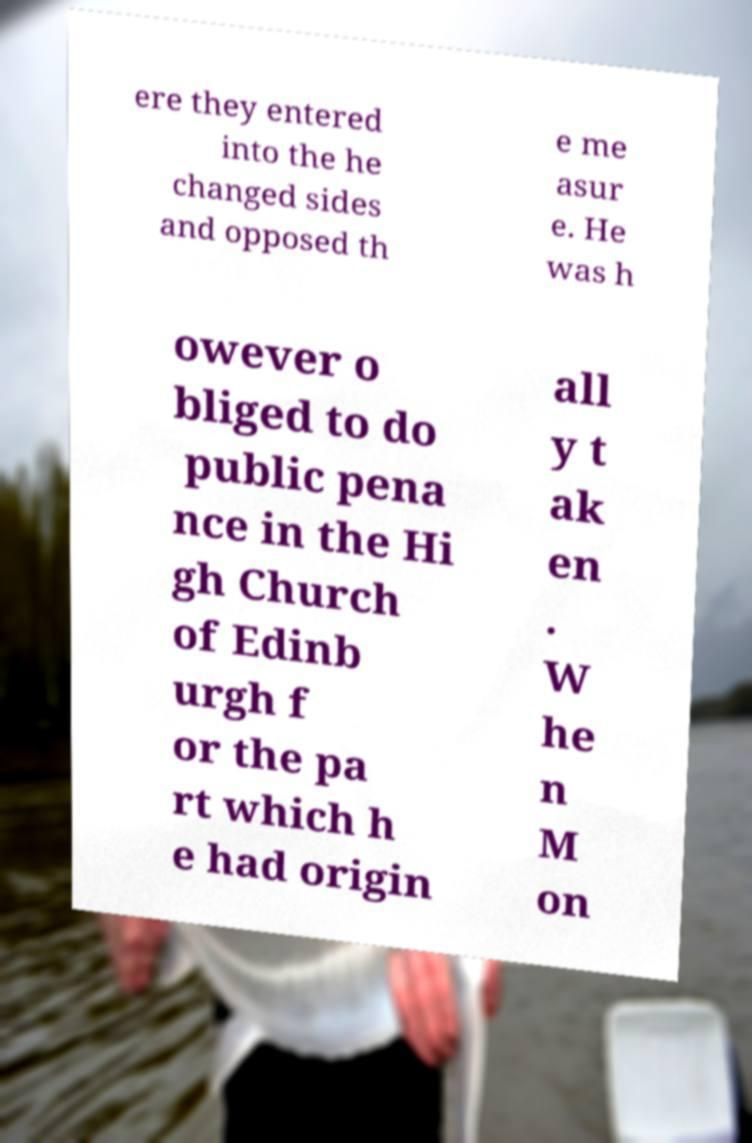There's text embedded in this image that I need extracted. Can you transcribe it verbatim? ere they entered into the he changed sides and opposed th e me asur e. He was h owever o bliged to do public pena nce in the Hi gh Church of Edinb urgh f or the pa rt which h e had origin all y t ak en . W he n M on 